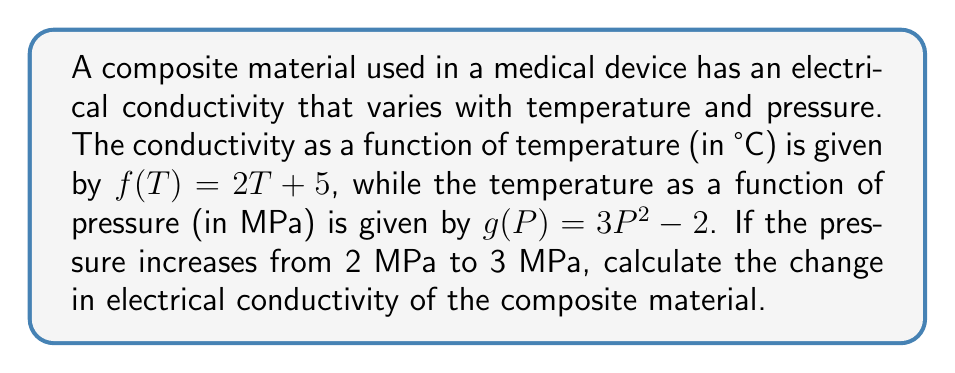Solve this math problem. To solve this problem, we need to use function composition and follow these steps:

1) First, we need to compose the functions $f$ and $g$ to get the conductivity as a function of pressure:
   $$(f \circ g)(P) = f(g(P)) = f(3P^2 - 2) = 2(3P^2 - 2) + 5 = 6P^2 - 4 + 5 = 6P^2 + 1$$

2) Now we can calculate the conductivity at 2 MPa:
   $$(f \circ g)(2) = 6(2)^2 + 1 = 6(4) + 1 = 24 + 1 = 25$$

3) And the conductivity at 3 MPa:
   $$(f \circ g)(3) = 6(3)^2 + 1 = 6(9) + 1 = 54 + 1 = 55$$

4) The change in conductivity is the difference between these two values:
   $$\text{Change} = (f \circ g)(3) - (f \circ g)(2) = 55 - 25 = 30$$

Therefore, the change in electrical conductivity when the pressure increases from 2 MPa to 3 MPa is 30 units.
Answer: 30 